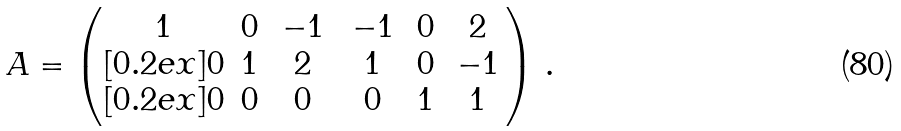Convert formula to latex. <formula><loc_0><loc_0><loc_500><loc_500>A = \begin{pmatrix} 1 & 0 & \, - 1 \, & \, - 1 \, & 0 & 2 \\ [ 0 . 2 e x ] 0 & 1 & 2 & 1 & 0 & \, - 1 \, \\ [ 0 . 2 e x ] 0 & 0 & 0 & 0 & 1 & 1 \end{pmatrix} \, .</formula> 